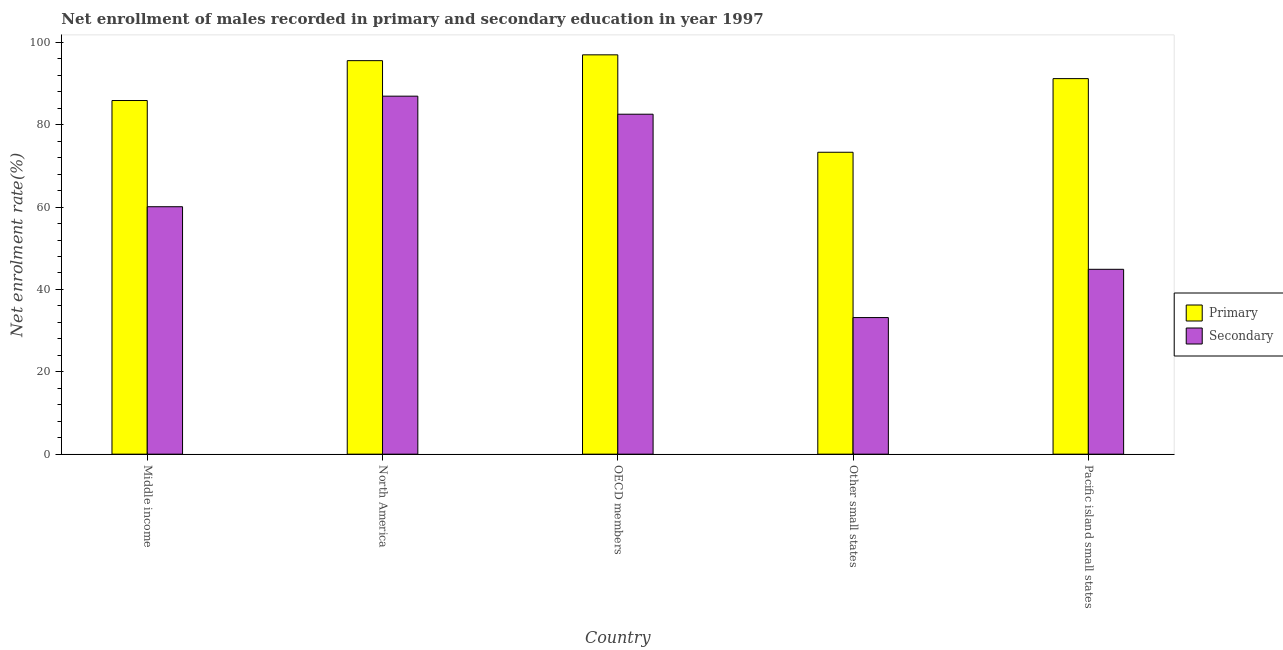How many groups of bars are there?
Ensure brevity in your answer.  5. Are the number of bars per tick equal to the number of legend labels?
Your answer should be compact. Yes. Are the number of bars on each tick of the X-axis equal?
Provide a short and direct response. Yes. What is the label of the 5th group of bars from the left?
Give a very brief answer. Pacific island small states. In how many cases, is the number of bars for a given country not equal to the number of legend labels?
Offer a terse response. 0. What is the enrollment rate in primary education in Pacific island small states?
Your answer should be very brief. 91.19. Across all countries, what is the maximum enrollment rate in secondary education?
Offer a very short reply. 86.92. Across all countries, what is the minimum enrollment rate in primary education?
Keep it short and to the point. 73.31. In which country was the enrollment rate in primary education maximum?
Your response must be concise. OECD members. In which country was the enrollment rate in primary education minimum?
Give a very brief answer. Other small states. What is the total enrollment rate in primary education in the graph?
Provide a succinct answer. 442.87. What is the difference between the enrollment rate in secondary education in North America and that in Pacific island small states?
Offer a terse response. 42.04. What is the difference between the enrollment rate in primary education in OECD members and the enrollment rate in secondary education in Middle income?
Keep it short and to the point. 36.88. What is the average enrollment rate in secondary education per country?
Your answer should be compact. 61.52. What is the difference between the enrollment rate in primary education and enrollment rate in secondary education in Other small states?
Your answer should be very brief. 40.14. What is the ratio of the enrollment rate in secondary education in Middle income to that in OECD members?
Offer a terse response. 0.73. Is the enrollment rate in primary education in North America less than that in Other small states?
Provide a succinct answer. No. Is the difference between the enrollment rate in primary education in Middle income and North America greater than the difference between the enrollment rate in secondary education in Middle income and North America?
Offer a very short reply. Yes. What is the difference between the highest and the second highest enrollment rate in secondary education?
Your response must be concise. 4.38. What is the difference between the highest and the lowest enrollment rate in secondary education?
Provide a succinct answer. 53.76. Is the sum of the enrollment rate in secondary education in Middle income and OECD members greater than the maximum enrollment rate in primary education across all countries?
Make the answer very short. Yes. What does the 1st bar from the left in Pacific island small states represents?
Offer a very short reply. Primary. What does the 2nd bar from the right in Pacific island small states represents?
Offer a very short reply. Primary. How many bars are there?
Keep it short and to the point. 10. Are all the bars in the graph horizontal?
Offer a very short reply. No. Are the values on the major ticks of Y-axis written in scientific E-notation?
Offer a very short reply. No. Does the graph contain any zero values?
Provide a succinct answer. No. Does the graph contain grids?
Provide a succinct answer. No. How many legend labels are there?
Provide a succinct answer. 2. What is the title of the graph?
Your answer should be very brief. Net enrollment of males recorded in primary and secondary education in year 1997. What is the label or title of the Y-axis?
Provide a succinct answer. Net enrolment rate(%). What is the Net enrolment rate(%) in Primary in Middle income?
Your response must be concise. 85.87. What is the Net enrolment rate(%) in Secondary in Middle income?
Your answer should be very brief. 60.08. What is the Net enrolment rate(%) of Primary in North America?
Keep it short and to the point. 95.55. What is the Net enrolment rate(%) of Secondary in North America?
Your response must be concise. 86.92. What is the Net enrolment rate(%) in Primary in OECD members?
Give a very brief answer. 96.96. What is the Net enrolment rate(%) in Secondary in OECD members?
Your response must be concise. 82.54. What is the Net enrolment rate(%) in Primary in Other small states?
Your response must be concise. 73.31. What is the Net enrolment rate(%) in Secondary in Other small states?
Provide a succinct answer. 33.17. What is the Net enrolment rate(%) of Primary in Pacific island small states?
Your response must be concise. 91.19. What is the Net enrolment rate(%) of Secondary in Pacific island small states?
Make the answer very short. 44.89. Across all countries, what is the maximum Net enrolment rate(%) in Primary?
Your answer should be compact. 96.96. Across all countries, what is the maximum Net enrolment rate(%) of Secondary?
Offer a very short reply. 86.92. Across all countries, what is the minimum Net enrolment rate(%) in Primary?
Your answer should be compact. 73.31. Across all countries, what is the minimum Net enrolment rate(%) of Secondary?
Give a very brief answer. 33.17. What is the total Net enrolment rate(%) in Primary in the graph?
Ensure brevity in your answer.  442.87. What is the total Net enrolment rate(%) of Secondary in the graph?
Ensure brevity in your answer.  307.6. What is the difference between the Net enrolment rate(%) in Primary in Middle income and that in North America?
Keep it short and to the point. -9.68. What is the difference between the Net enrolment rate(%) in Secondary in Middle income and that in North America?
Make the answer very short. -26.84. What is the difference between the Net enrolment rate(%) of Primary in Middle income and that in OECD members?
Your response must be concise. -11.09. What is the difference between the Net enrolment rate(%) in Secondary in Middle income and that in OECD members?
Offer a very short reply. -22.47. What is the difference between the Net enrolment rate(%) in Primary in Middle income and that in Other small states?
Make the answer very short. 12.56. What is the difference between the Net enrolment rate(%) in Secondary in Middle income and that in Other small states?
Offer a very short reply. 26.91. What is the difference between the Net enrolment rate(%) in Primary in Middle income and that in Pacific island small states?
Ensure brevity in your answer.  -5.32. What is the difference between the Net enrolment rate(%) of Secondary in Middle income and that in Pacific island small states?
Offer a very short reply. 15.19. What is the difference between the Net enrolment rate(%) of Primary in North America and that in OECD members?
Keep it short and to the point. -1.41. What is the difference between the Net enrolment rate(%) of Secondary in North America and that in OECD members?
Provide a succinct answer. 4.38. What is the difference between the Net enrolment rate(%) in Primary in North America and that in Other small states?
Your answer should be compact. 22.24. What is the difference between the Net enrolment rate(%) in Secondary in North America and that in Other small states?
Keep it short and to the point. 53.76. What is the difference between the Net enrolment rate(%) of Primary in North America and that in Pacific island small states?
Keep it short and to the point. 4.36. What is the difference between the Net enrolment rate(%) in Secondary in North America and that in Pacific island small states?
Provide a short and direct response. 42.04. What is the difference between the Net enrolment rate(%) of Primary in OECD members and that in Other small states?
Keep it short and to the point. 23.65. What is the difference between the Net enrolment rate(%) of Secondary in OECD members and that in Other small states?
Provide a succinct answer. 49.38. What is the difference between the Net enrolment rate(%) of Primary in OECD members and that in Pacific island small states?
Keep it short and to the point. 5.77. What is the difference between the Net enrolment rate(%) of Secondary in OECD members and that in Pacific island small states?
Your answer should be compact. 37.66. What is the difference between the Net enrolment rate(%) of Primary in Other small states and that in Pacific island small states?
Give a very brief answer. -17.88. What is the difference between the Net enrolment rate(%) of Secondary in Other small states and that in Pacific island small states?
Your response must be concise. -11.72. What is the difference between the Net enrolment rate(%) in Primary in Middle income and the Net enrolment rate(%) in Secondary in North America?
Provide a short and direct response. -1.06. What is the difference between the Net enrolment rate(%) of Primary in Middle income and the Net enrolment rate(%) of Secondary in OECD members?
Provide a short and direct response. 3.32. What is the difference between the Net enrolment rate(%) in Primary in Middle income and the Net enrolment rate(%) in Secondary in Other small states?
Make the answer very short. 52.7. What is the difference between the Net enrolment rate(%) in Primary in Middle income and the Net enrolment rate(%) in Secondary in Pacific island small states?
Keep it short and to the point. 40.98. What is the difference between the Net enrolment rate(%) in Primary in North America and the Net enrolment rate(%) in Secondary in OECD members?
Keep it short and to the point. 13. What is the difference between the Net enrolment rate(%) in Primary in North America and the Net enrolment rate(%) in Secondary in Other small states?
Ensure brevity in your answer.  62.38. What is the difference between the Net enrolment rate(%) of Primary in North America and the Net enrolment rate(%) of Secondary in Pacific island small states?
Offer a very short reply. 50.66. What is the difference between the Net enrolment rate(%) in Primary in OECD members and the Net enrolment rate(%) in Secondary in Other small states?
Offer a very short reply. 63.79. What is the difference between the Net enrolment rate(%) in Primary in OECD members and the Net enrolment rate(%) in Secondary in Pacific island small states?
Provide a succinct answer. 52.07. What is the difference between the Net enrolment rate(%) of Primary in Other small states and the Net enrolment rate(%) of Secondary in Pacific island small states?
Your answer should be compact. 28.42. What is the average Net enrolment rate(%) in Primary per country?
Ensure brevity in your answer.  88.57. What is the average Net enrolment rate(%) of Secondary per country?
Ensure brevity in your answer.  61.52. What is the difference between the Net enrolment rate(%) of Primary and Net enrolment rate(%) of Secondary in Middle income?
Make the answer very short. 25.79. What is the difference between the Net enrolment rate(%) in Primary and Net enrolment rate(%) in Secondary in North America?
Give a very brief answer. 8.62. What is the difference between the Net enrolment rate(%) in Primary and Net enrolment rate(%) in Secondary in OECD members?
Offer a terse response. 14.41. What is the difference between the Net enrolment rate(%) of Primary and Net enrolment rate(%) of Secondary in Other small states?
Offer a very short reply. 40.14. What is the difference between the Net enrolment rate(%) of Primary and Net enrolment rate(%) of Secondary in Pacific island small states?
Offer a very short reply. 46.3. What is the ratio of the Net enrolment rate(%) of Primary in Middle income to that in North America?
Ensure brevity in your answer.  0.9. What is the ratio of the Net enrolment rate(%) in Secondary in Middle income to that in North America?
Offer a very short reply. 0.69. What is the ratio of the Net enrolment rate(%) in Primary in Middle income to that in OECD members?
Your answer should be compact. 0.89. What is the ratio of the Net enrolment rate(%) in Secondary in Middle income to that in OECD members?
Give a very brief answer. 0.73. What is the ratio of the Net enrolment rate(%) in Primary in Middle income to that in Other small states?
Your response must be concise. 1.17. What is the ratio of the Net enrolment rate(%) in Secondary in Middle income to that in Other small states?
Your answer should be compact. 1.81. What is the ratio of the Net enrolment rate(%) in Primary in Middle income to that in Pacific island small states?
Keep it short and to the point. 0.94. What is the ratio of the Net enrolment rate(%) in Secondary in Middle income to that in Pacific island small states?
Your response must be concise. 1.34. What is the ratio of the Net enrolment rate(%) of Primary in North America to that in OECD members?
Your answer should be compact. 0.99. What is the ratio of the Net enrolment rate(%) in Secondary in North America to that in OECD members?
Give a very brief answer. 1.05. What is the ratio of the Net enrolment rate(%) in Primary in North America to that in Other small states?
Give a very brief answer. 1.3. What is the ratio of the Net enrolment rate(%) in Secondary in North America to that in Other small states?
Your response must be concise. 2.62. What is the ratio of the Net enrolment rate(%) of Primary in North America to that in Pacific island small states?
Make the answer very short. 1.05. What is the ratio of the Net enrolment rate(%) of Secondary in North America to that in Pacific island small states?
Your response must be concise. 1.94. What is the ratio of the Net enrolment rate(%) of Primary in OECD members to that in Other small states?
Offer a terse response. 1.32. What is the ratio of the Net enrolment rate(%) in Secondary in OECD members to that in Other small states?
Your answer should be compact. 2.49. What is the ratio of the Net enrolment rate(%) in Primary in OECD members to that in Pacific island small states?
Your answer should be very brief. 1.06. What is the ratio of the Net enrolment rate(%) of Secondary in OECD members to that in Pacific island small states?
Ensure brevity in your answer.  1.84. What is the ratio of the Net enrolment rate(%) of Primary in Other small states to that in Pacific island small states?
Your answer should be compact. 0.8. What is the ratio of the Net enrolment rate(%) of Secondary in Other small states to that in Pacific island small states?
Provide a short and direct response. 0.74. What is the difference between the highest and the second highest Net enrolment rate(%) in Primary?
Ensure brevity in your answer.  1.41. What is the difference between the highest and the second highest Net enrolment rate(%) of Secondary?
Give a very brief answer. 4.38. What is the difference between the highest and the lowest Net enrolment rate(%) of Primary?
Your answer should be very brief. 23.65. What is the difference between the highest and the lowest Net enrolment rate(%) of Secondary?
Your response must be concise. 53.76. 